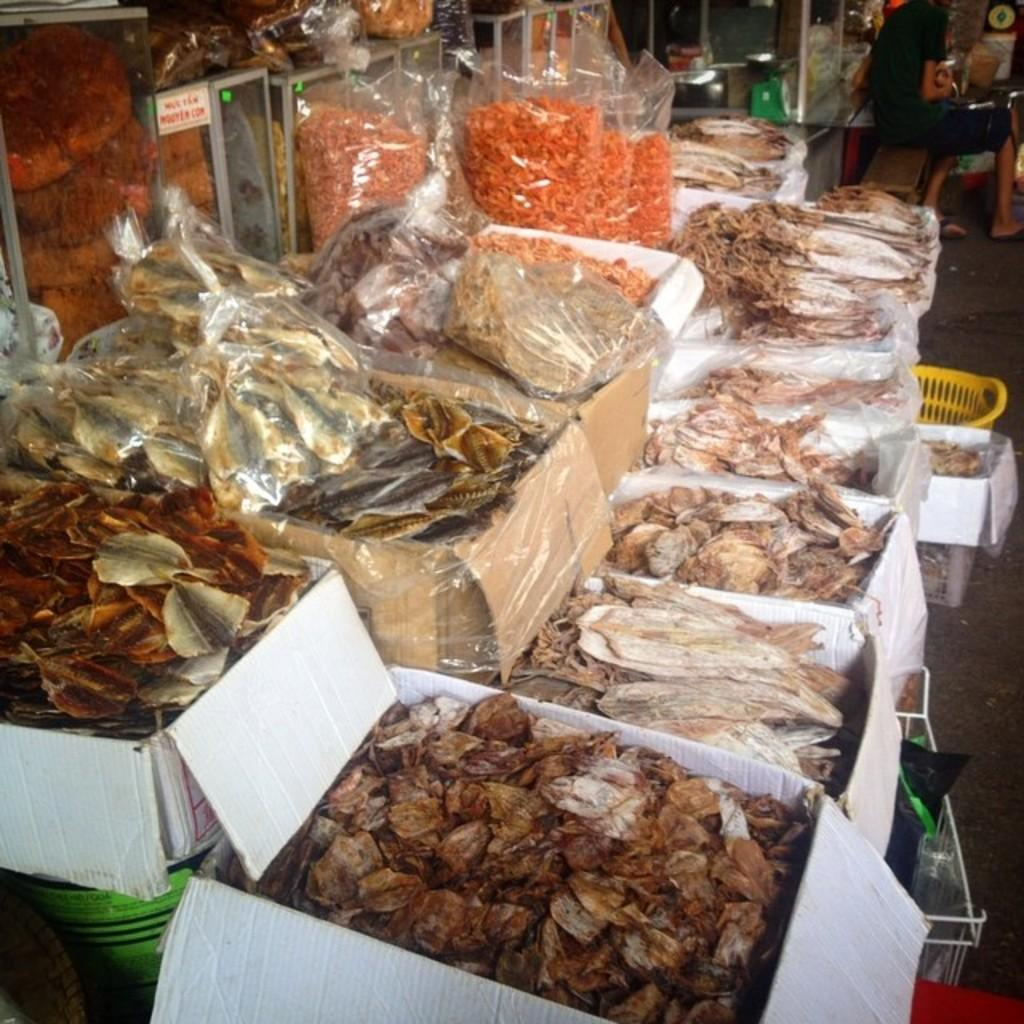What type of containers are used to pack the food items in the image? The food items are packed in cardboard boxes and covers in the image. What can be seen in the background of the image? There is a basket and a person visible in the background of the image. What is used to hold or display some items in the image? There are some things placed in a stand in the image. What type of rub is being used to clean the vase in the image? There is no vase or rub present in the image. What advertisement can be seen on the cardboard boxes in the image? There is no advertisement visible on the cardboard boxes in the image. 